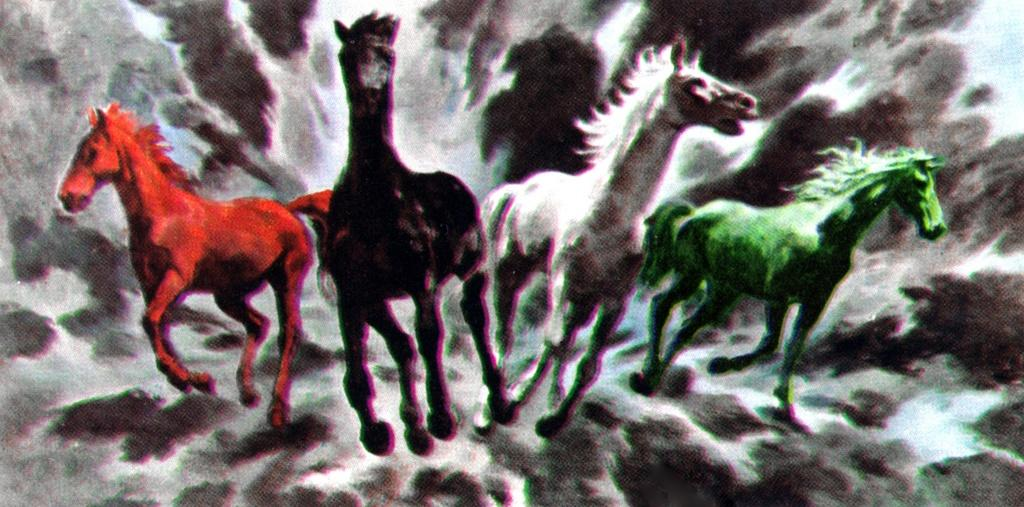What is the main subject of the image? There is a painting in the image. What is depicted in the painting? The painting depicts colorful horses. Where are the horses located in the painting? The horses are in the sky in the painting. What type of garden can be seen in the image? There is no garden present in the image; it features a painting of colorful horses in the sky. What is the weight of the cloud in the image? There is no cloud present in the image, as the horses are in the sky, not a cloud. 